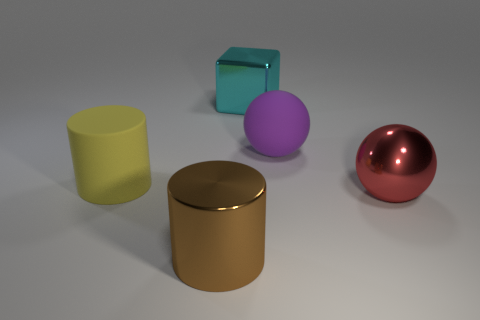Add 1 big red objects. How many objects exist? 6 Subtract all yellow cylinders. How many cylinders are left? 1 Subtract all cylinders. How many objects are left? 3 Subtract 2 cylinders. How many cylinders are left? 0 Subtract all gray spheres. How many gray blocks are left? 0 Add 3 rubber cylinders. How many rubber cylinders are left? 4 Add 2 large cyan things. How many large cyan things exist? 3 Subtract 0 purple blocks. How many objects are left? 5 Subtract all brown cubes. Subtract all brown cylinders. How many cubes are left? 1 Subtract all large blue things. Subtract all big cyan things. How many objects are left? 4 